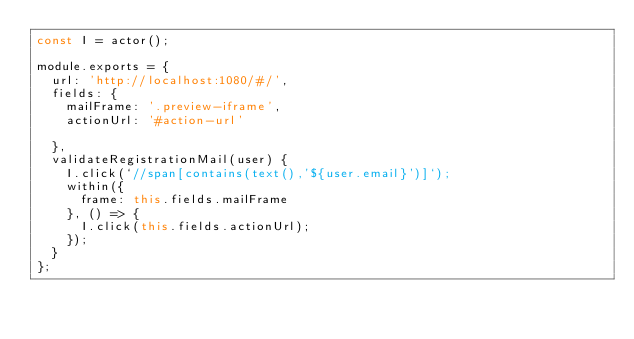<code> <loc_0><loc_0><loc_500><loc_500><_JavaScript_>const I = actor();

module.exports = {
  url: 'http://localhost:1080/#/',
  fields: {
    mailFrame: '.preview-iframe',
    actionUrl: '#action-url'

  },
  validateRegistrationMail(user) {
    I.click(`//span[contains(text(),'${user.email}')]`);
    within({
      frame: this.fields.mailFrame
    }, () => {
      I.click(this.fields.actionUrl);
    });
  }
};
</code> 